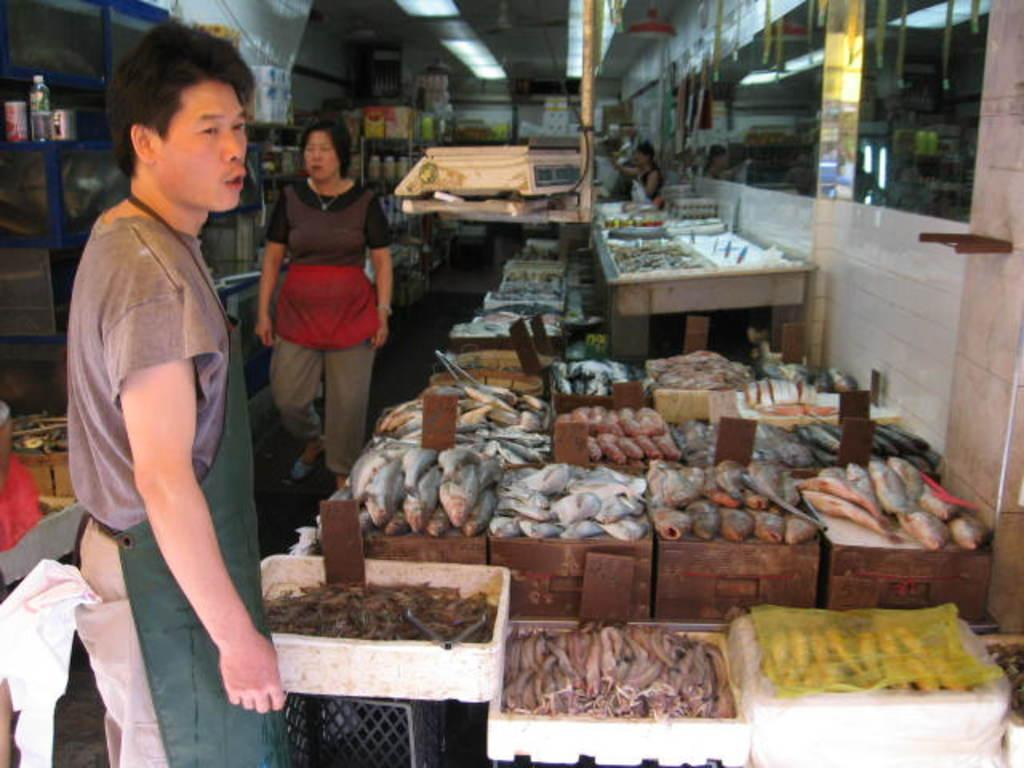How many people are in the image? There are two people standing in the image. What are the people wearing? The people are wearing different color dresses. What can be seen in the image besides the people? There are fish visible in the image, and they are on wooden boxes. What color are the white objects in the image? The white objects in the image are not described in terms of color, but they are mentioned as being present. What type of furniture is in the image? There are tables in the image. What type of pies are being sold at the market in the image? There is no mention of a market or pies in the image; it features two people, fish on wooden boxes, white objects, and tables. 